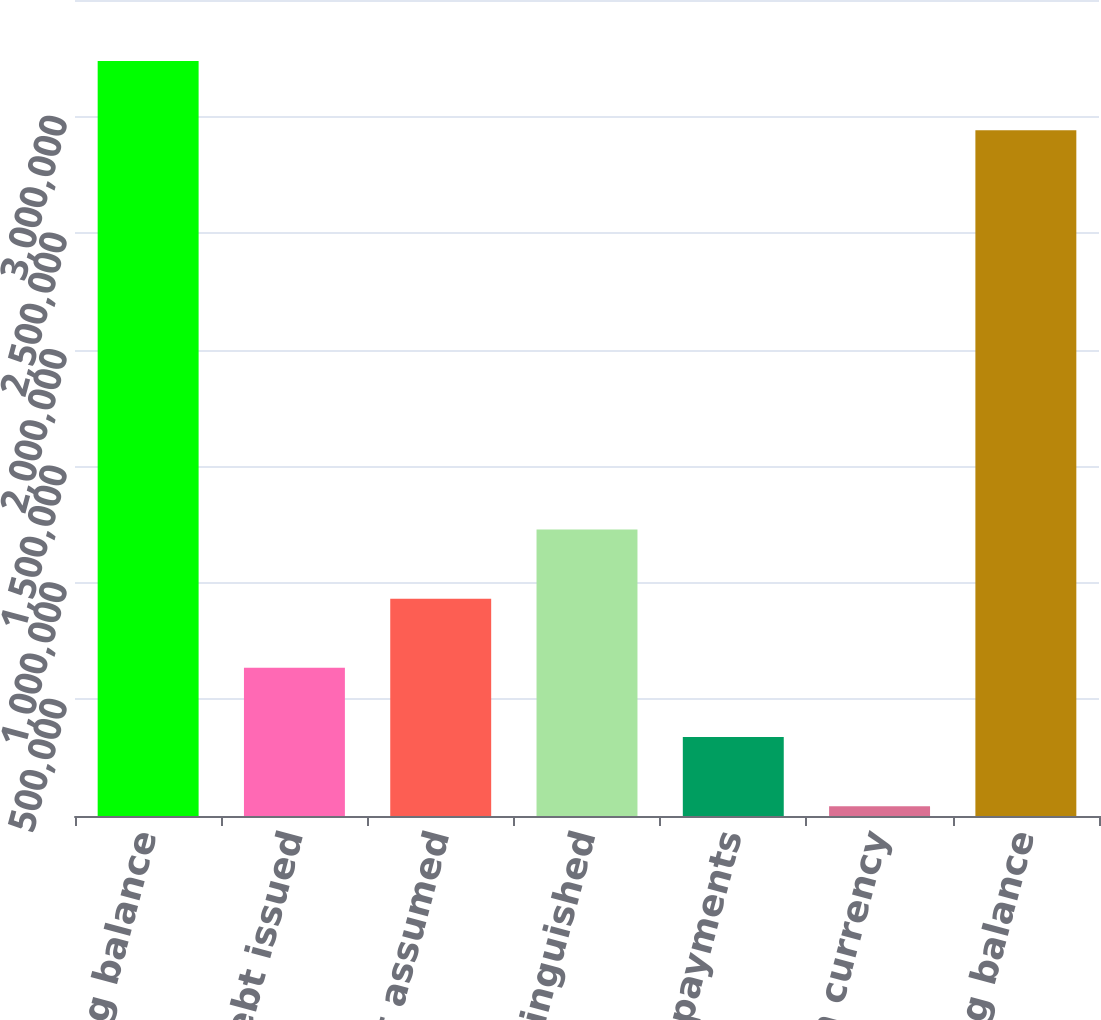<chart> <loc_0><loc_0><loc_500><loc_500><bar_chart><fcel>Beginning balance<fcel>Debt issued<fcel>Debt assumed<fcel>Debt extinguished<fcel>Principal payments<fcel>Foreign currency<fcel>Ending balance<nl><fcel>3.23868e+06<fcel>635389<fcel>932305<fcel>1.22922e+06<fcel>338474<fcel>41559<fcel>2.94176e+06<nl></chart> 